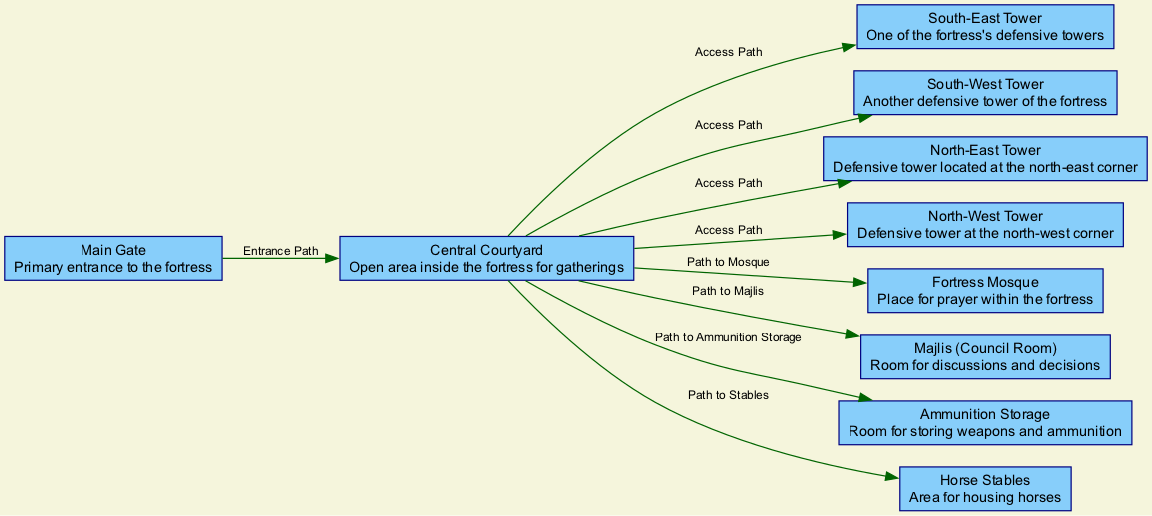What is the primary entrance to the fortress? The diagram identifies the "Main Gate" as the primary entrance to the fortress. It clearly labels this node to indicate its significance as the main access point.
Answer: Main Gate How many defensive towers are there in the fortress? The diagram lists four defensive towers, labeled as the South-East Tower, South-West Tower, North-East Tower, and North-West Tower. Counting these nodes gives the total number of defensive towers.
Answer: 4 What is the purpose of the central courtyard? According to the diagram, the central courtyard serves as an "Open area inside the fortress for gatherings." This descriptor indicates its function as a communal space within the fortress.
Answer: Central Courtyard Which room is designated for discussions and decisions? The diagram specifies the "Majlis (Council Room)" as the room for discussions and decisions. This designation indicates the room's intended use and importance within the fortress layout.
Answer: Majlis (Council Room) What are the two paths leading from the central courtyard? The diagram illustrates multiple paths from the courtyard, including Path to Mosque and Path to Stables, indicating direction to two specific areas. These paths connect the central space to key locations within the fortress.
Answer: Path to Mosque, Path to Stables How many total nodes are represented in the diagram? By counting all specified nodes, such as the main gate, courtyard, towers, mosque, majlis, ammunition room, and stables, the total number of nodes can be determined. There are ten distinct nodes in total.
Answer: 10 Which room serves as a place for prayer? The diagram identifies the "Fortress Mosque" specifically as the room designated for prayer, highlighting its religious role within the fortress layout.
Answer: Fortress Mosque What connects the main gate to the courtyard? The diagram indicates an "Entrance Path" connecting the Main Gate to the Central Courtyard, showing the direct access route into the fortress.
Answer: Entrance Path What is located at the north-east corner of the fortress? The diagram labels the "North-East Tower" as being located at the north-east corner of the fortress. This designation specifies both its position and name.
Answer: North-East Tower 